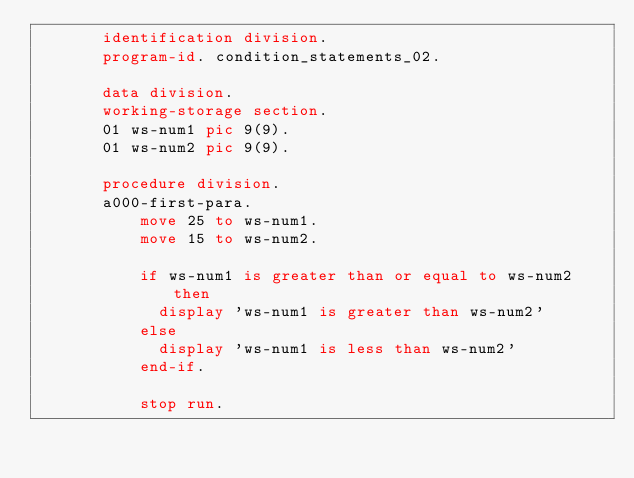<code> <loc_0><loc_0><loc_500><loc_500><_COBOL_>       identification division.
       program-id. condition_statements_02.

       data division.
       working-storage section.
       01 ws-num1 pic 9(9).
       01 ws-num2 pic 9(9).

       procedure division.
       a000-first-para.
           move 25 to ws-num1.
           move 15 to ws-num2.

           if ws-num1 is greater than or equal to ws-num2 then
             display 'ws-num1 is greater than ws-num2'
           else
             display 'ws-num1 is less than ws-num2'
           end-if.

           stop run.
</code> 